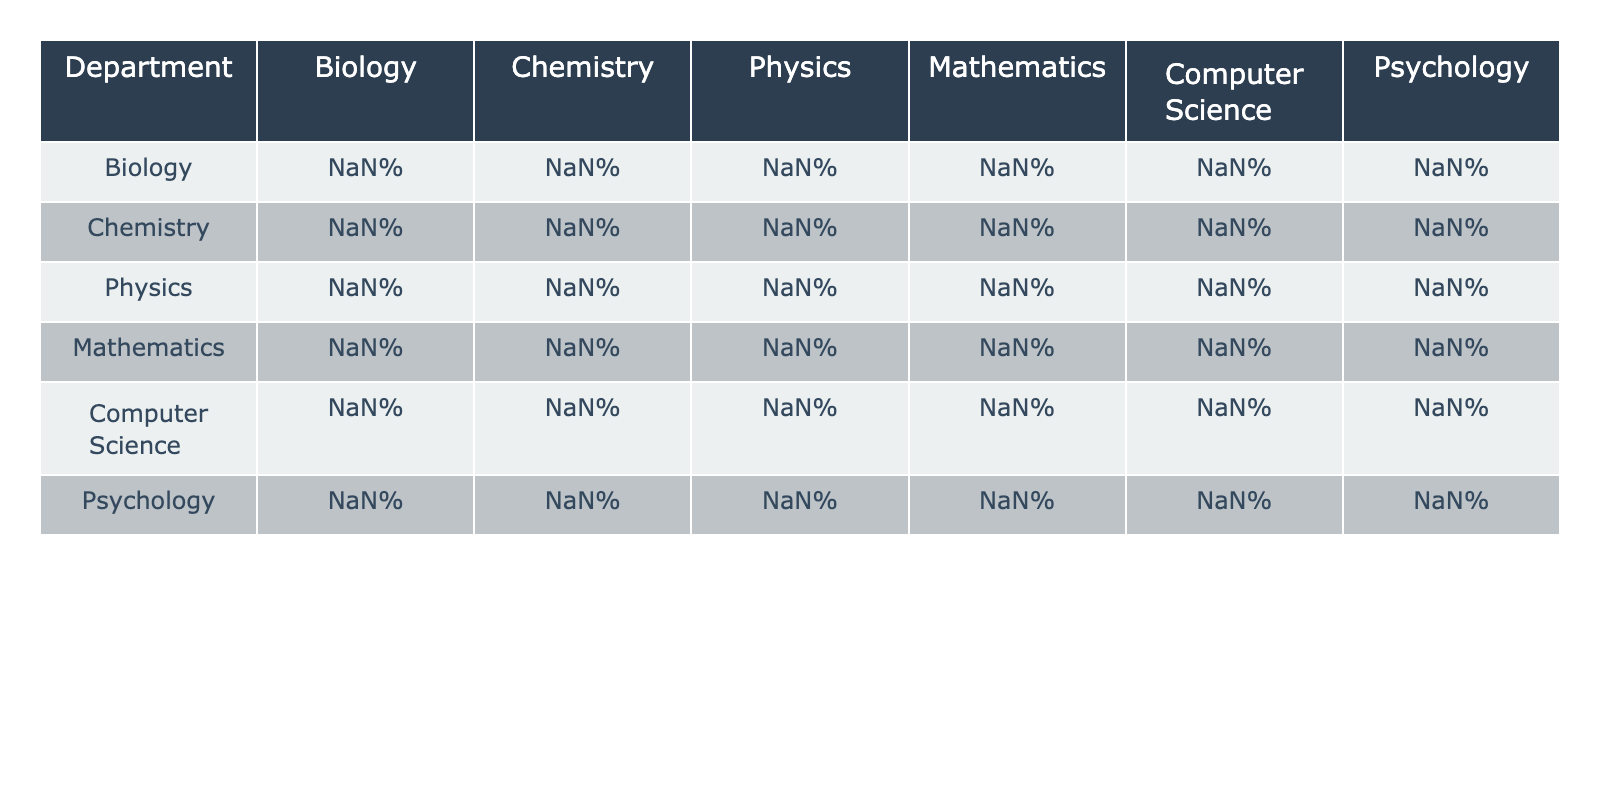What is the success rate of the Biology department when integrating courses with Psychology? The table indicates that the Biology department has a success rate of 78% when integrating with the Psychology department.
Answer: 78% Which department has the highest integration success rate in Physics? Looking at the Physics column, we can see that the highest success rate is 90%, which belongs to the Physics department itself.
Answer: 90% What is the lowest integration success rate between Computer Science and other departments? By checking the Computer Science row, the lowest success rate is 59%, which occurs in its integration with Biology.
Answer: 59% What is the average success rate of the Chemistry department when integrating with other departments? To find the average, sum the success rates for Chemistry (72%, 88%, 76%, 70%, 65%, 63%) which totals to 434%. Dividing this by 5 gives an average of 86.8%.
Answer: 86.8% Is the integration success rate of Psychology with Mathematics higher than that of Chemistry with Physics? The rate for Psychology and Mathematics is 52%, while for Chemistry and Physics it is 76%. Since 52% is less than 76%, the statement is false.
Answer: No Which department benefits the most from integration with other departments based on the maximum rate? The data shows that Physics has a maximum integration success rate of 90%. Based on this, it can be concluded that Physics benefits the most.
Answer: Physics What is the difference in success rates between the highest and lowest integration rates for Mathematics? The highest integration rate for Mathematics (92% with Mathematics itself) minus the lowest (52% with Psychology) gives a difference of 40%.
Answer: 40% Which department has the least overall average in integration success rates? Calculating the averages of each department indicates that Psychology has the lowest average success rate of 69.5%.
Answer: Psychology Are there any departments that integrate better with all other departments than Mathematics does? The data shows that Mathematics has a maximum rate of 92%. Checking other departments, only Physics integrates better with itself at 90% which does not surpass Mathematics’ peak. Hence, no other department outperforms Mathematics overall.
Answer: No What is the integration success rate of Computer Science with Mathematics? The value in the table for Computer Science integrating with Mathematics is 79%.
Answer: 79% 